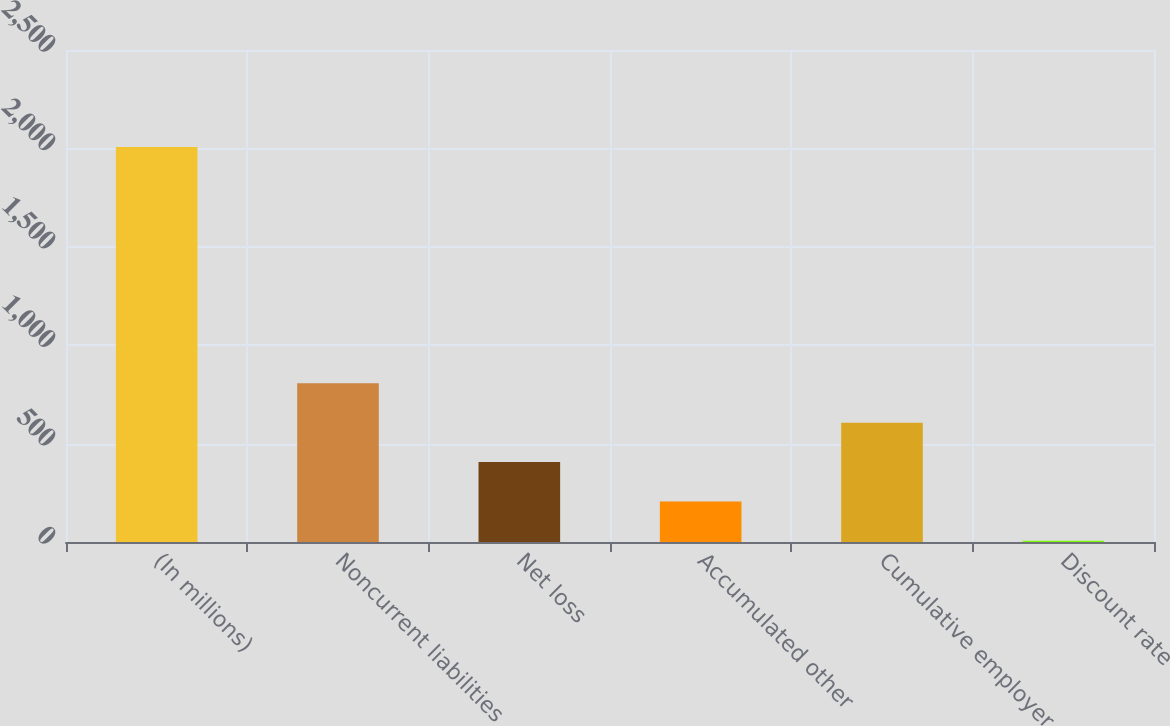Convert chart. <chart><loc_0><loc_0><loc_500><loc_500><bar_chart><fcel>(In millions)<fcel>Noncurrent liabilities<fcel>Net loss<fcel>Accumulated other<fcel>Cumulative employer<fcel>Discount rate<nl><fcel>2007<fcel>806.4<fcel>406.2<fcel>206.1<fcel>606.3<fcel>6<nl></chart> 